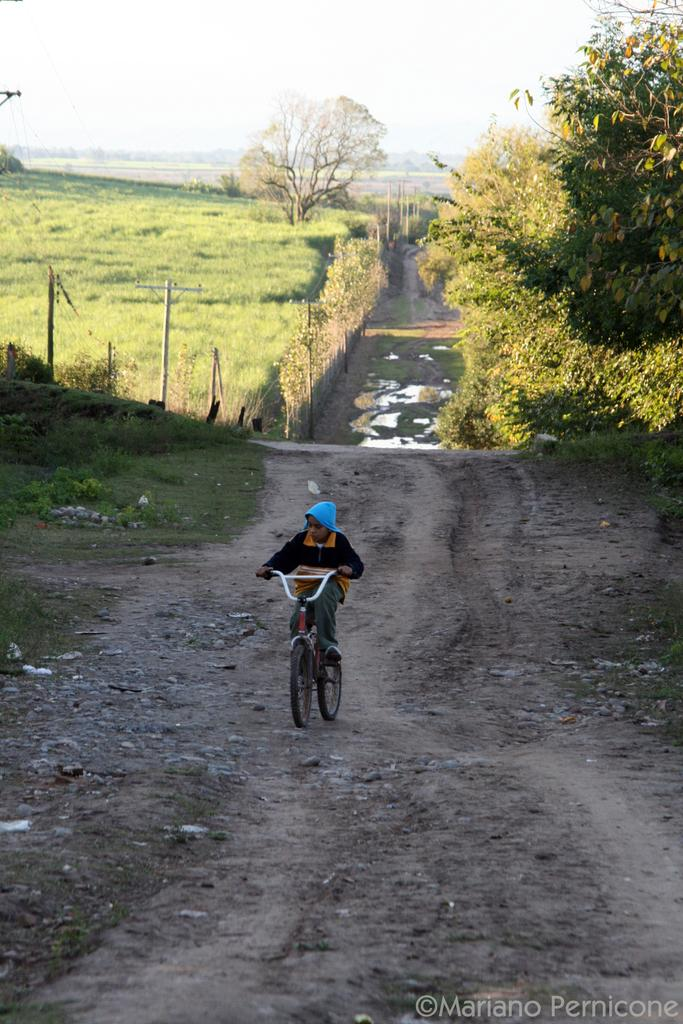Who is the main subject in the image? There is a boy in the image. What is the boy doing in the image? The boy is riding a bicycle. What type of terrain can be seen in the image? There is grass visible in the image. What other natural elements are present in the image? There are trees in the image. What type of barrier is visible in the image? There is fencing in the image. What is visible at the top of the image? The sky is visible at the top of the image. What is the size of the question mark in the image? There is no question mark present in the image. What type of trade is being conducted in the image? There is no trade being conducted in the image; it features a boy riding a bicycle. 